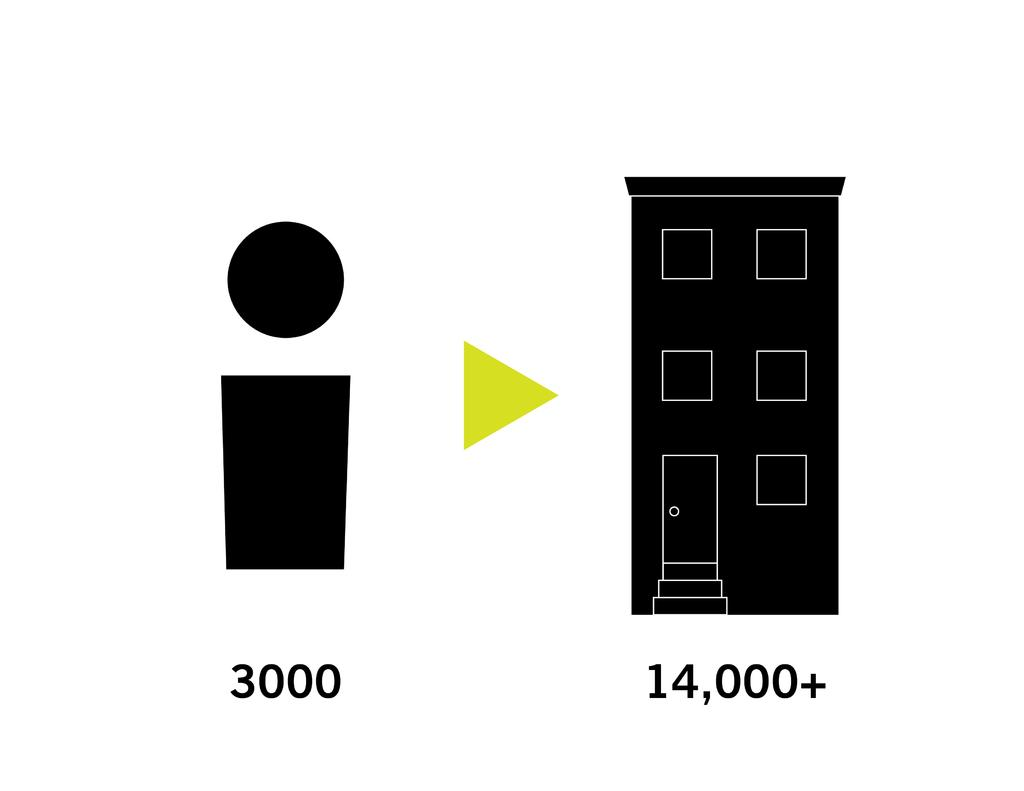Provide a one-sentence caption for the provided image. A figure of a body with 3000 under it with an arrow towards a building with 14,000+ under it. 